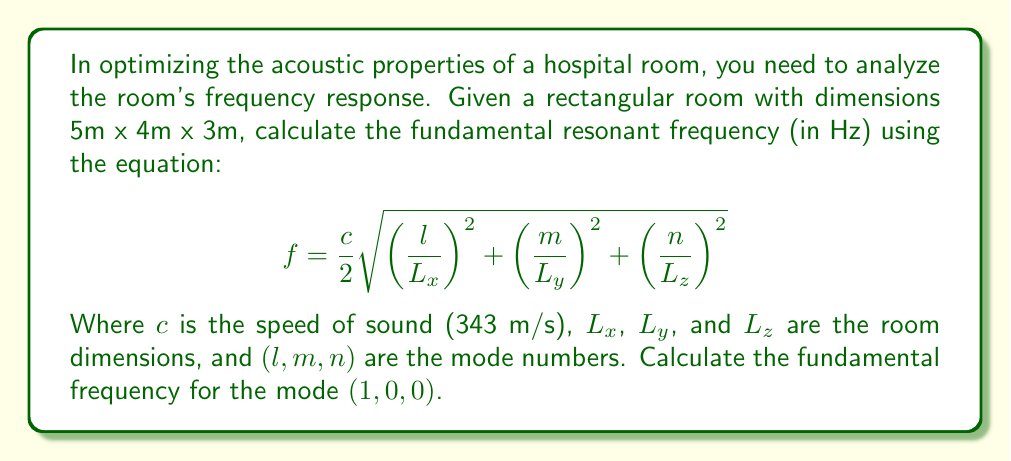Show me your answer to this math problem. To solve this problem, we'll follow these steps:

1) Identify the given values:
   $c = 343$ m/s
   $L_x = 5$ m
   $L_y = 4$ m
   $L_z = 3$ m
   $(l,m,n) = (1,0,0)$

2) Substitute these values into the equation:

   $$ f = \frac{343}{2} \sqrt{\left(\frac{1}{5}\right)^2 + \left(\frac{0}{4}\right)^2 + \left(\frac{0}{3}\right)^2} $$

3) Simplify inside the square root:

   $$ f = \frac{343}{2} \sqrt{0.04 + 0 + 0} = \frac{343}{2} \sqrt{0.04} $$

4) Calculate the square root:

   $$ f = \frac{343}{2} \cdot 0.2 = 34.3 $$

5) Round to the nearest whole number:

   $$ f \approx 34 \text{ Hz} $$

This fundamental frequency represents the lowest resonant frequency of the room in the x-direction, which is crucial for understanding and optimizing the room's acoustic behavior.
Answer: 34 Hz 